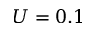<formula> <loc_0><loc_0><loc_500><loc_500>U = 0 . 1</formula> 